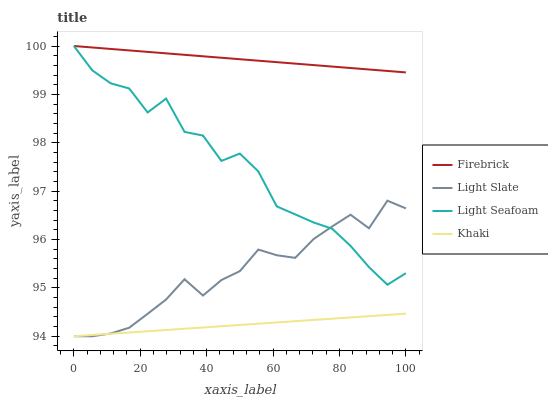Does Khaki have the minimum area under the curve?
Answer yes or no. Yes. Does Firebrick have the maximum area under the curve?
Answer yes or no. Yes. Does Light Seafoam have the minimum area under the curve?
Answer yes or no. No. Does Light Seafoam have the maximum area under the curve?
Answer yes or no. No. Is Firebrick the smoothest?
Answer yes or no. Yes. Is Light Seafoam the roughest?
Answer yes or no. Yes. Is Light Seafoam the smoothest?
Answer yes or no. No. Is Firebrick the roughest?
Answer yes or no. No. Does Light Slate have the lowest value?
Answer yes or no. Yes. Does Light Seafoam have the lowest value?
Answer yes or no. No. Does Light Seafoam have the highest value?
Answer yes or no. Yes. Does Khaki have the highest value?
Answer yes or no. No. Is Light Slate less than Firebrick?
Answer yes or no. Yes. Is Light Seafoam greater than Khaki?
Answer yes or no. Yes. Does Light Slate intersect Light Seafoam?
Answer yes or no. Yes. Is Light Slate less than Light Seafoam?
Answer yes or no. No. Is Light Slate greater than Light Seafoam?
Answer yes or no. No. Does Light Slate intersect Firebrick?
Answer yes or no. No. 